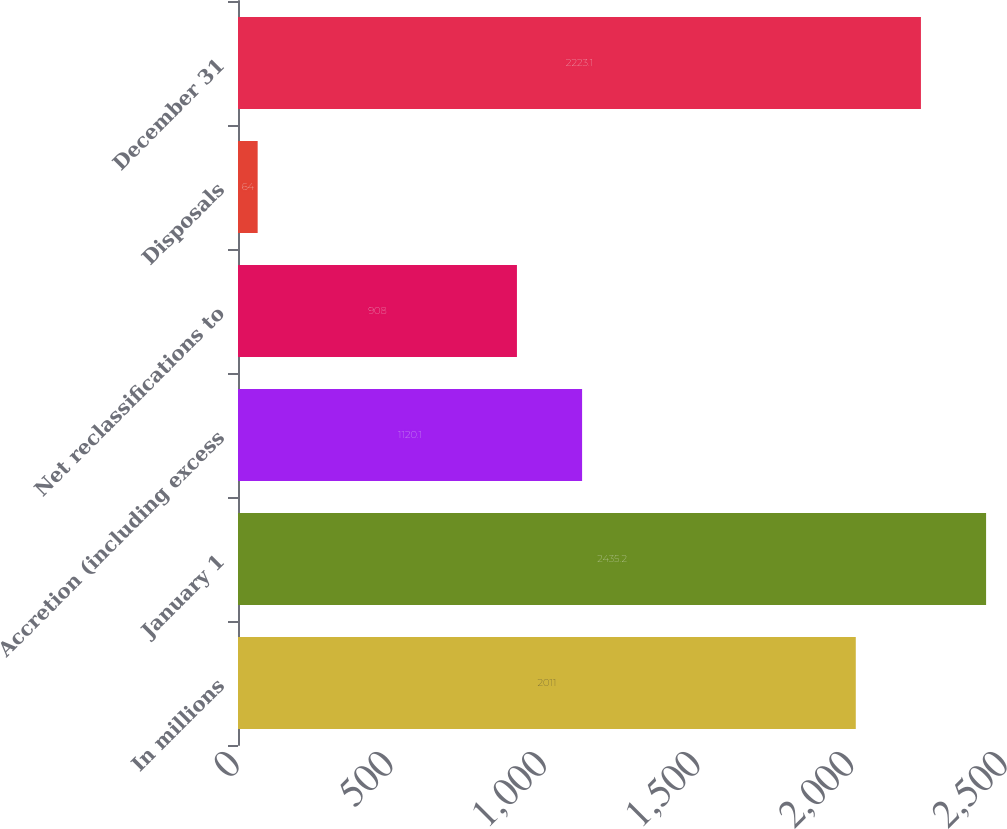Convert chart. <chart><loc_0><loc_0><loc_500><loc_500><bar_chart><fcel>In millions<fcel>January 1<fcel>Accretion (including excess<fcel>Net reclassifications to<fcel>Disposals<fcel>December 31<nl><fcel>2011<fcel>2435.2<fcel>1120.1<fcel>908<fcel>64<fcel>2223.1<nl></chart> 